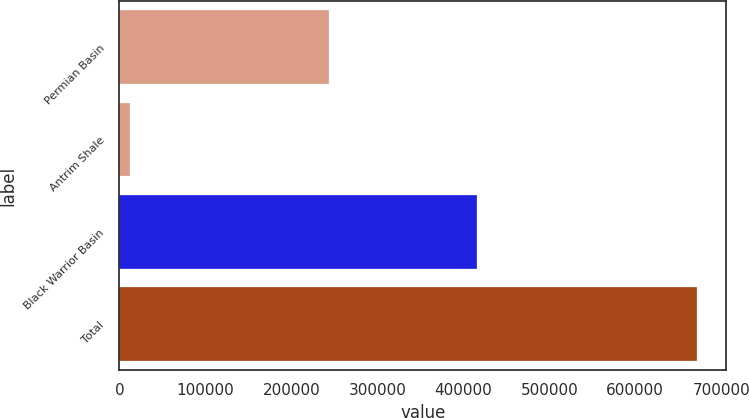<chart> <loc_0><loc_0><loc_500><loc_500><bar_chart><fcel>Permian Basin<fcel>Antrim Shale<fcel>Black Warrior Basin<fcel>Total<nl><fcel>244034<fcel>12114<fcel>415909<fcel>672057<nl></chart> 